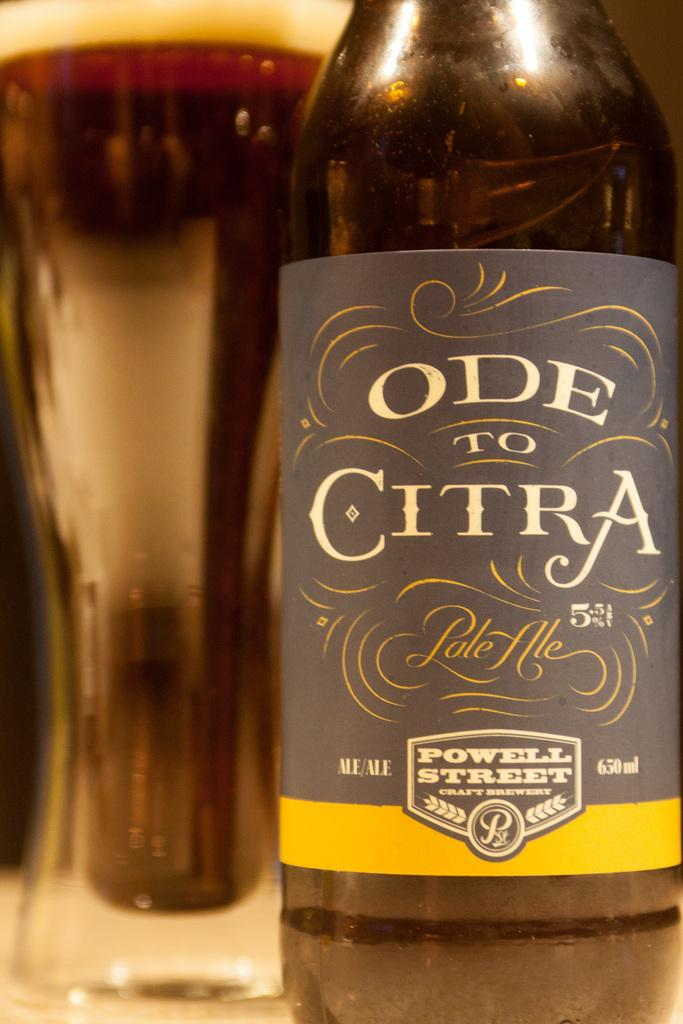Provide a one-sentence caption for the provided image. A bottle of Ode to Citra pale ale has a gray and yellow label. 